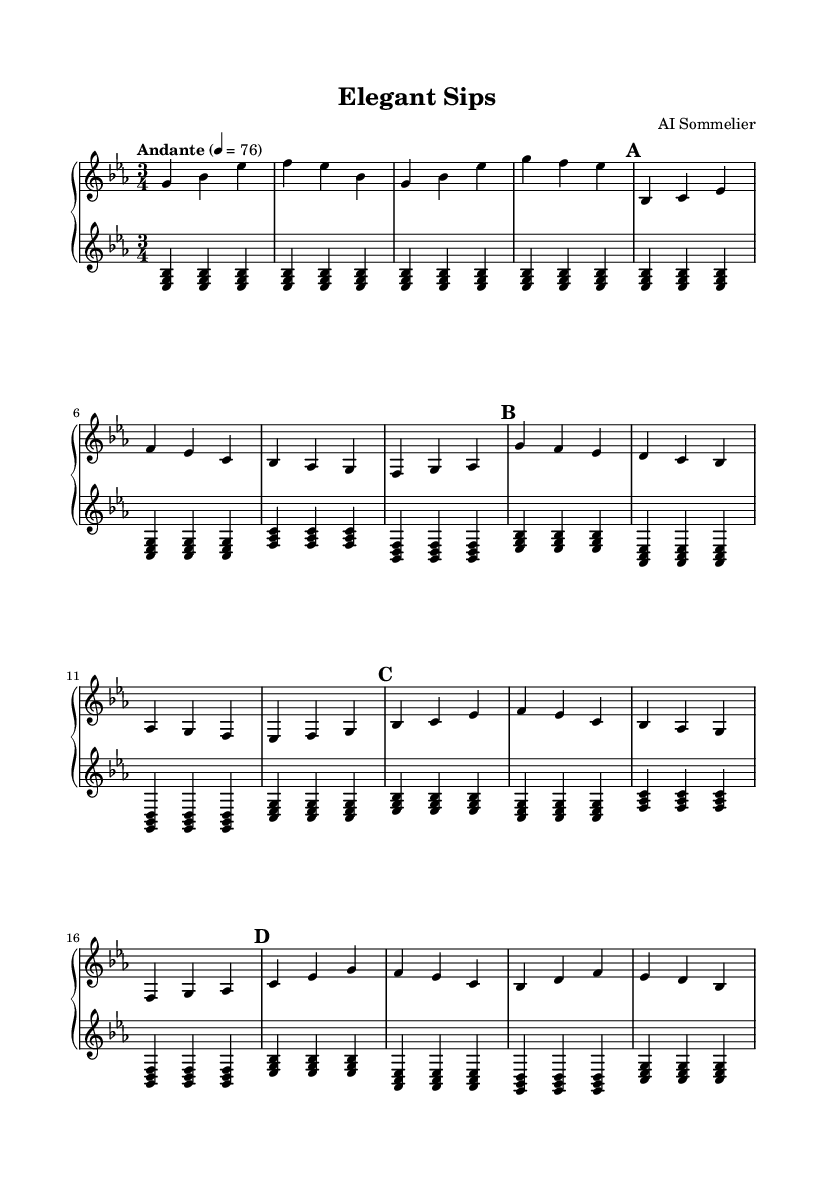What is the key signature of this music? The key signature is indicated at the beginning of the score. It shows three flats, which is characteristic of E-flat major or C minor. The context suggests E-flat major is the key since the piece has a generally uplifting character.
Answer: E-flat major What is the time signature of this music? The time signature is located at the beginning of the score, and it is represented as 3/4. This means that there are three beats per measure and the quarter note receives one beat.
Answer: 3/4 What is the tempo marking of this piece? The tempo marking appears at the beginning of the score, stating "Andante" and a metronome marking of quarter note equals 76. This indicates a moderate walking pace for the music.
Answer: Andante How many distinct sections are present in this composition? The sheet music shows clearly defined sections labeled as Intro, A, B, A', and C. Each section has a repeating structure or theme. Counting these labeled sections gives five distinct parts.
Answer: 5 What is the primary mood conveyed by this composition? The overall structure and dynamics in the sheet music suggest a sophisticated and elegant mood, reflecting the ambiance of high-end dining experiences. This is inferred from the flowing lines and gentle tempo.
Answer: Elegant Which part contains a repeated theme? The A and A' sections are clearly labeled as the same theme, with A' being a variation of the original A section. This signifies that the A part has been repeated with some minor changes.
Answer: A and A' What is the role of the lower staff in this composition? The lower staff primarily supports the upper melody with harmonizing chords and bass notes. It provides a harmonic foundation, giving depth and texture to the melodic elements presented in the upper staff.
Answer: Harmonic foundation 